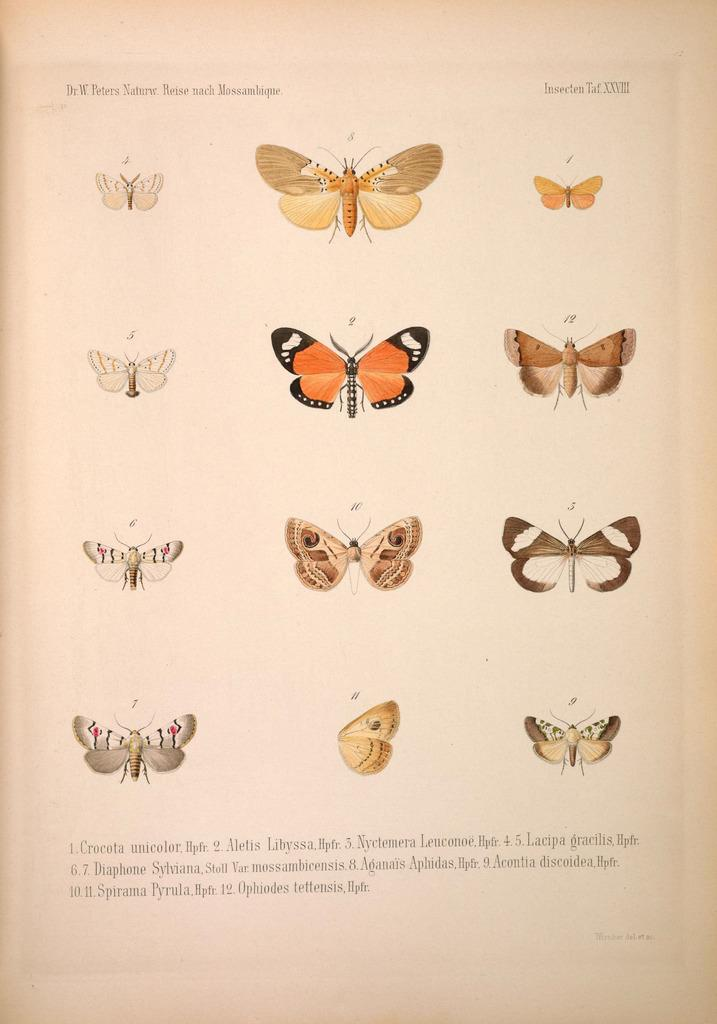What is depicted on the paper in the image? The paper contains pictures of butterflies. What else can be found on the paper besides the butterfly images? There is writing on the paper. What color is the eye of the butterfly in the image? There is no eye visible in the image, as it only contains pictures of butterflies, not actual butterflies. 